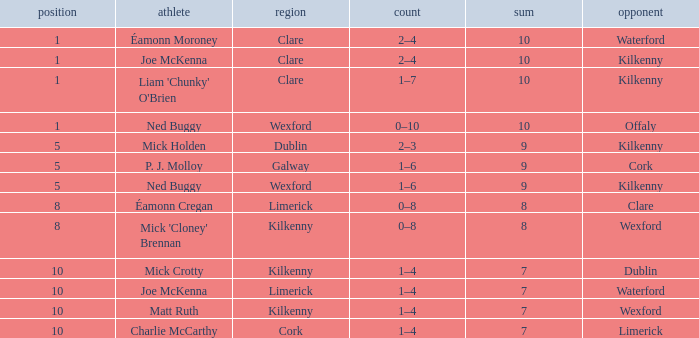What is galway county's total? 9.0. 